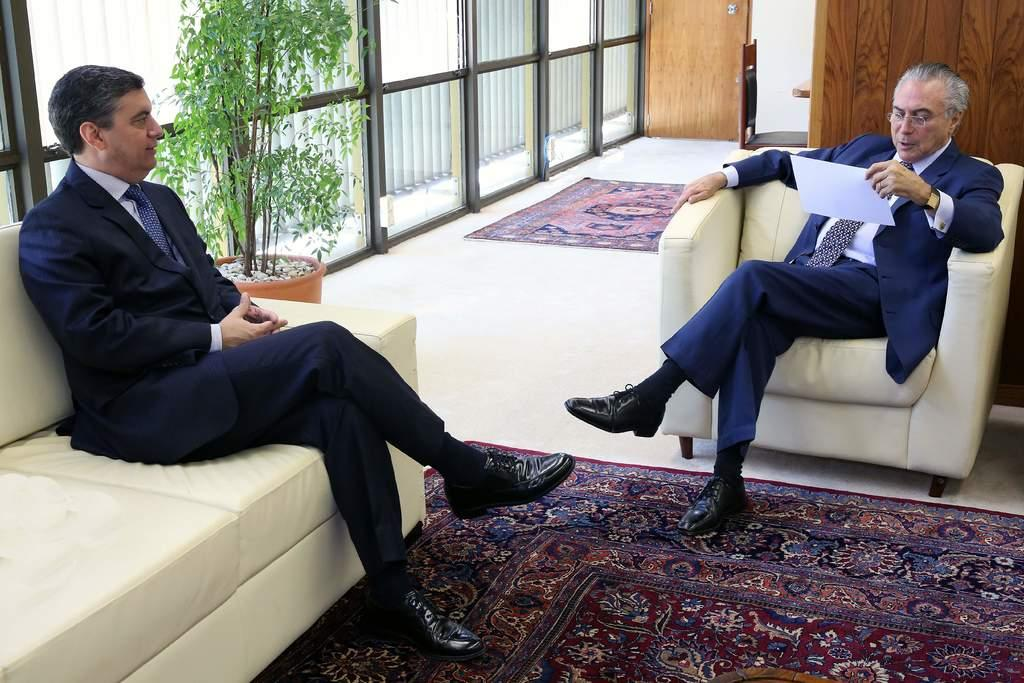What can be seen through the windows in the image? The details about what can be seen through the windows are not provided in the facts. What type of plant is in the image? The type of plant in the image is not specified in the facts. What are the two people sitting on in the image? The two people are sitting on sofas in the image. What is on the floor in the image? There are mats on the floor in the image. How does the plant affect the stomach of the people in the image? There is no information about the plant's effect on the people's stomachs in the image. How many people are sitting on the sofas in the image? The facts only mention that there are two people sitting on sofas in the image. Is there any poison present in the image? There is no mention of poison in the image or the provided facts. 